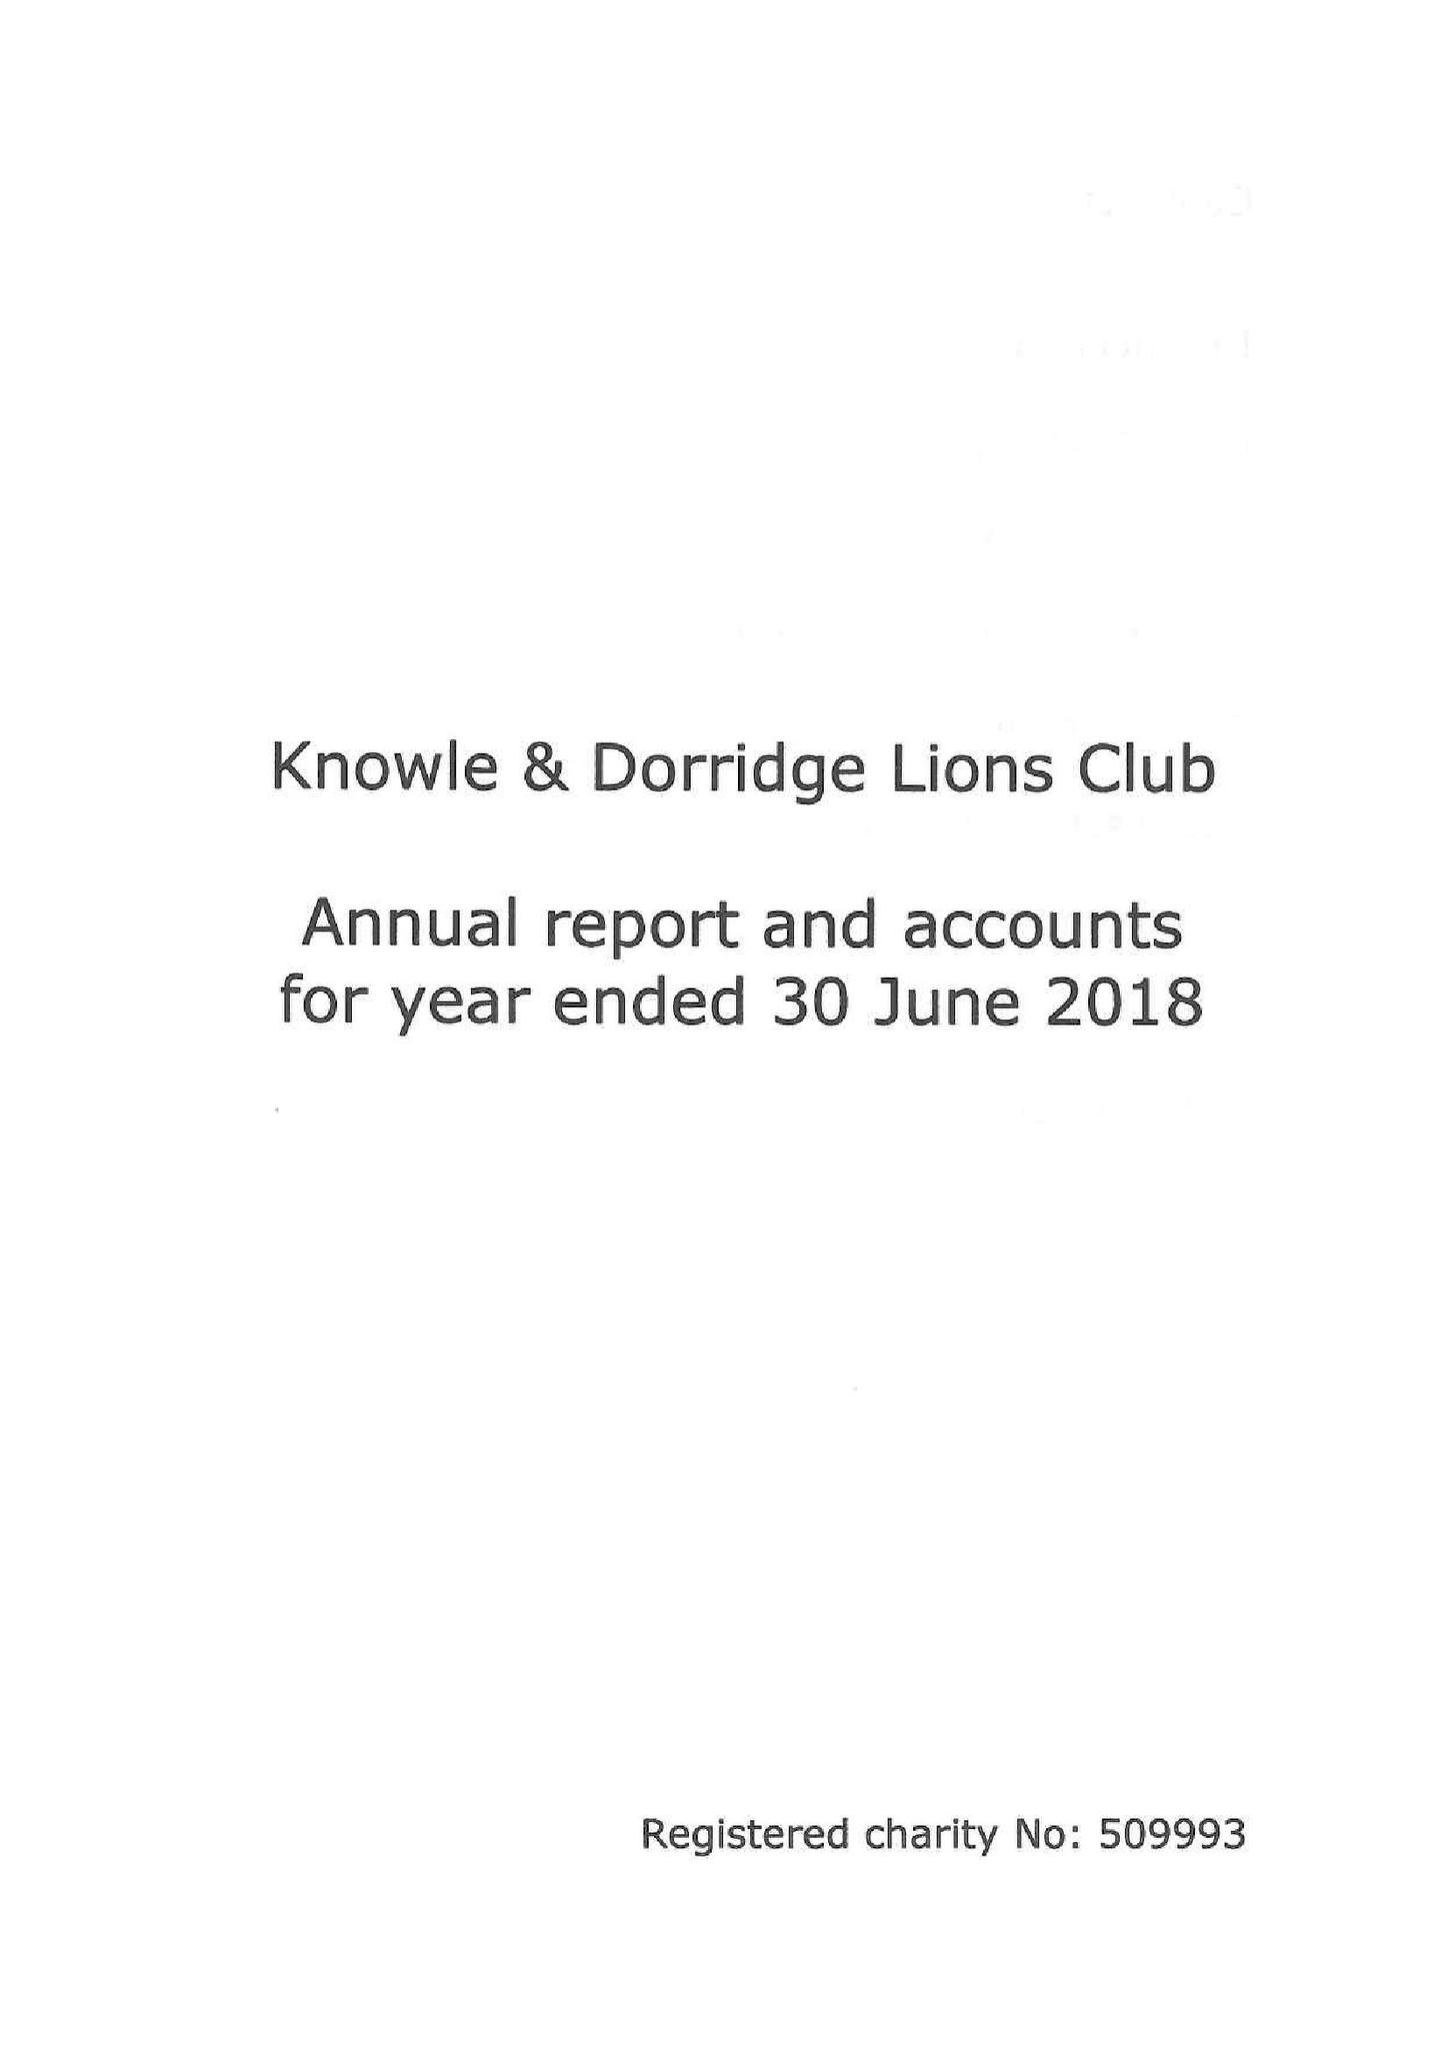What is the value for the address__post_town?
Answer the question using a single word or phrase. SOLIHULL 